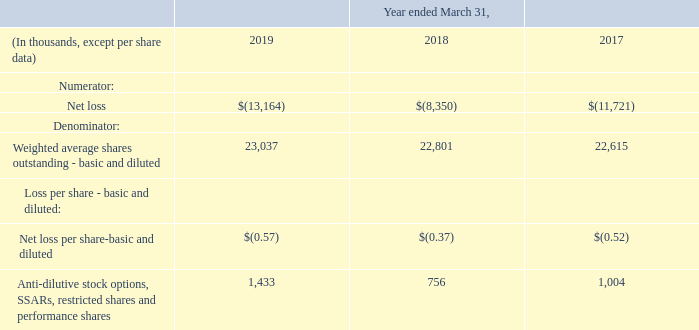13. Loss per Share
The following data shows the amounts used in computing loss per share and the effect on earnings and the weighted average number of shares of dilutive potential common shares.
Basic earnings (loss) per share is computed as net income available to common shareholders divided by the weighted average basic shares outstanding. The outstanding shares used to calculate the weighted average basic shares excludes 300,437, 334,817 and 490,355 of restricted shares and performance shares at March 31, 2019, 2018 and 2017, respectively, as these shares were issued but were not vested and, therefore, not considered outstanding for purposes of computing basic earnings per share at the balance sheet dates.
Diluted earnings (loss) per share includes the effect of all potentially dilutive securities on earnings per share. We have stock options, stock-settled appreciation rights ("SSARs"), unvested restricted shares and unvested performance shares that are potentially dilutive securities. When a loss is reported, the denominator of diluted earnings per share cannot be adjusted for the dilutive impact of sharebased compensation awards because doing so would be anti-dilutive.
In addition, when a net loss is reported, adjusting the denominator of diluted earnings per share would also be anti-dilutive to the loss per share, even if the entity has net income after adjusting for a discontinued operation. Therefore, for all periods presented, basic weighted-average shares outstanding were used in calculating the diluted net loss per share.
What is the Net loss for 2019?
Answer scale should be: thousand. $(13,164). What does the table show? The amounts used in computing loss per share and the effect on earnings and the weighted average number of shares of dilutive potential common shares. Which shares were used in calculating the diluted net loss per share? Basic weighted-average shares outstanding. What was the increase / (decrease) in the net loss from 2018 to 2019?
Answer scale should be: thousand. -13,164 - (- 8,350)
Answer: -4814. What was the percentage increase / (decrease) in Weighted average shares outstanding - basic and diluted from 2018 to 2019?
Answer scale should be: percent. 23,037 / 22,801 - 1
Answer: 1.04. What was the average Anti-dilutive stock options, SSARs, restricted shares and performance shares for 2017-2019?
Answer scale should be: thousand. (1,433 + 756 + 1,004) / 3
Answer: 1064.33. 